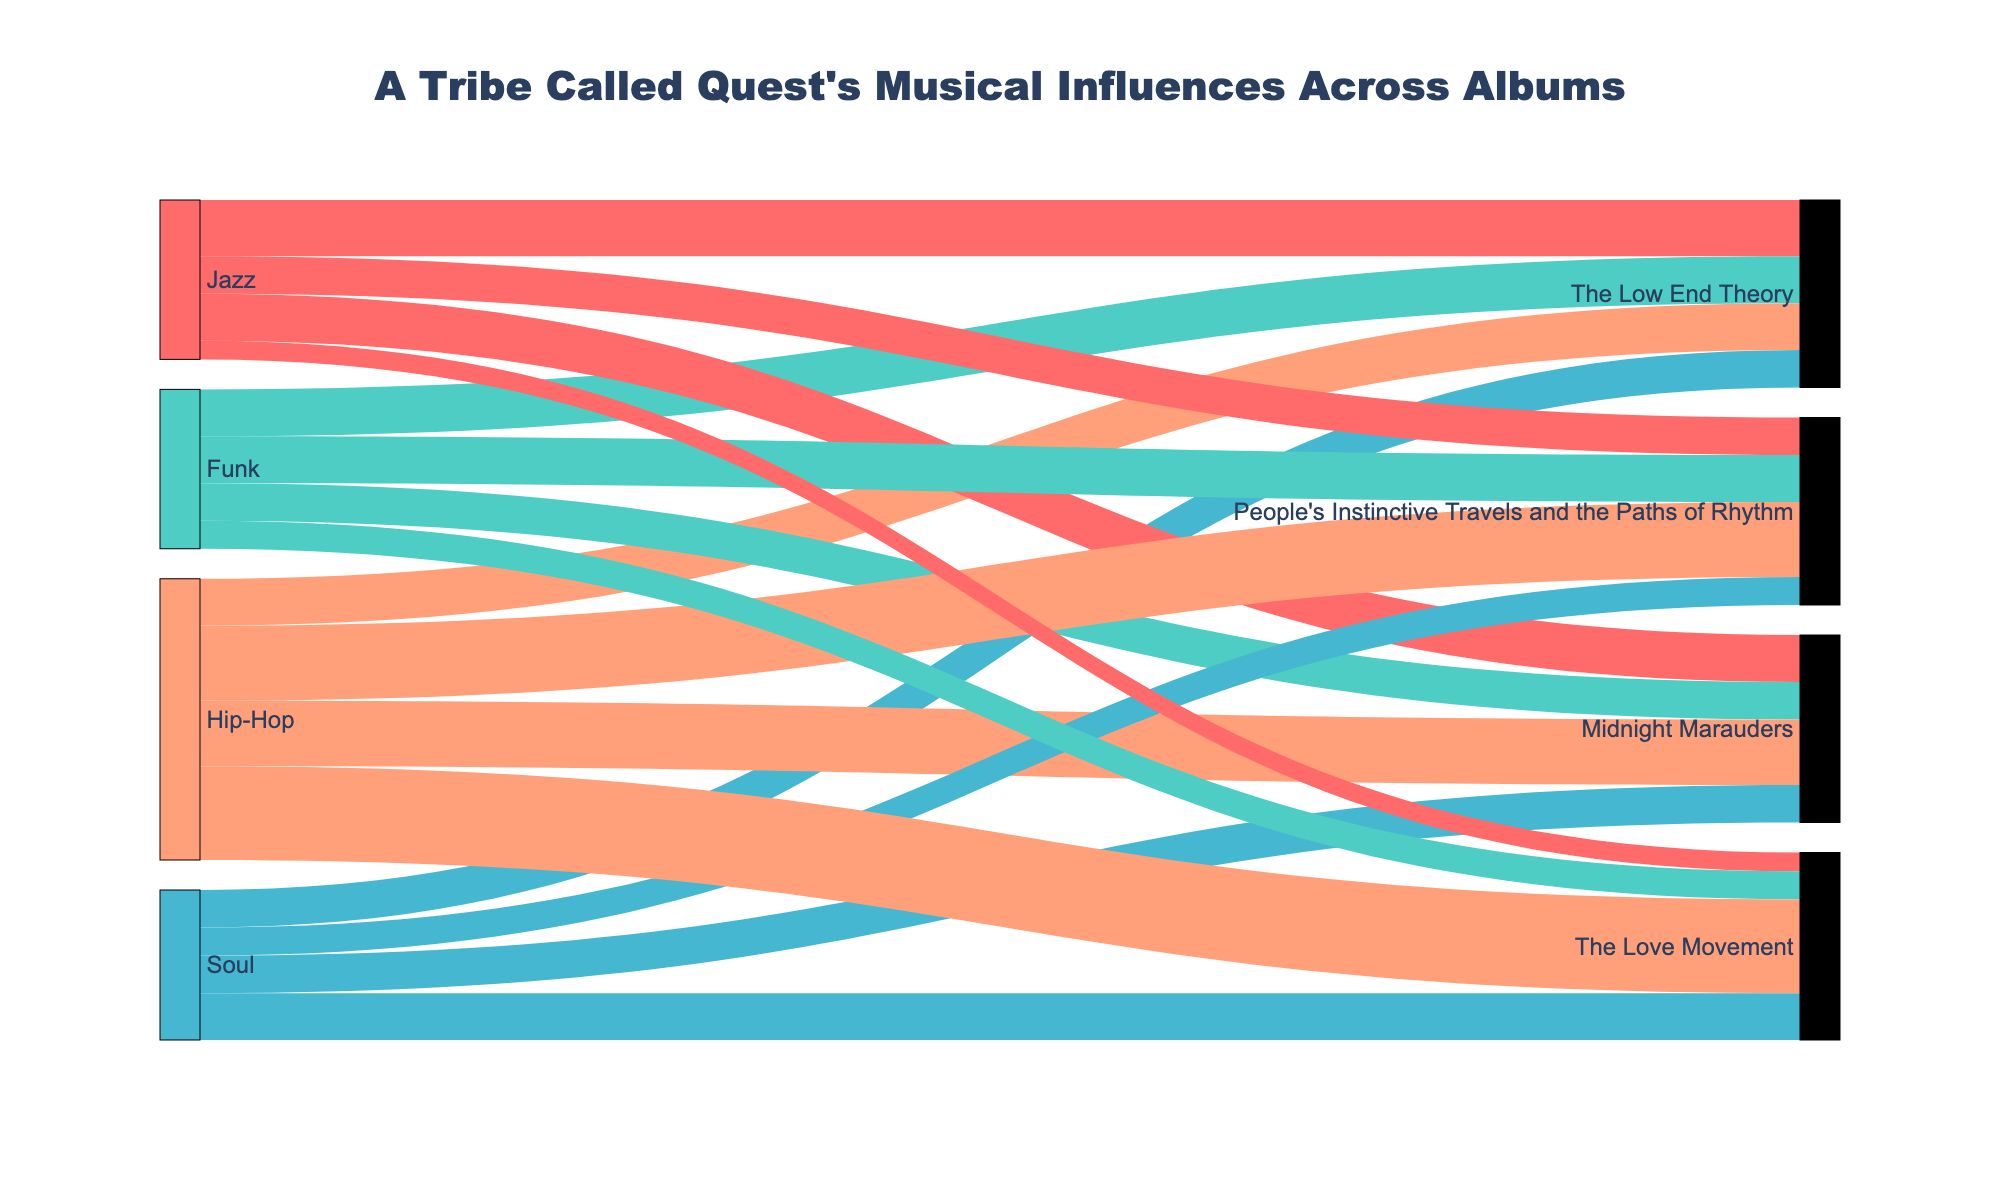What's the title of the figure? The title can be found at the top of the figure. It usually provides a summary of what the figure is about.
Answer: A Tribe Called Quest's Musical Influences Across Albums How many types of musical influences are shown? Identify the unique types of sources listed in the left part of the Sankey diagram.
Answer: Four (Jazz, Funk, Soul, Hip-Hop) How many albums are represented in the Sankey diagram? Look at the labels on the right side of the Sankey diagram, as these represent different albums.
Answer: Four (The Low End Theory, Midnight Marauders, People's Instinctive Travels and the Paths of Rhythm, The Love Movement) Which album has the highest influence from Hip-Hop? Compare the value of Hip-Hop influences for each album and find the highest number.
Answer: The Love Movement What's the combined influence of Funk on "Midnight Marauders" and "People's Instinctive Travels and the Paths of Rhythm"? Add the values of Funk influence on these two albums: 20 for Midnight Marauders and 25 for People's Instinctive Travels and the Paths of Rhythm.
Answer: 45 Which influence varies the least across the albums? Determine the range (difference between maximum and minimum values) of each influence across the albums. The smallest range indicates the least variation.
Answer: Soul What's the total Hip-Hop influence across all albums? Sum the values of Hip-Hop influences from all albums: 25 + 35 + 40 + 50.
Answer: 150 Which album has the lowest influence from Jazz? Compare the values of Jazz influences for each album and find the smallest number.
Answer: The Love Movement Rank the albums by the amount of Funk influence, highest to lowest. Order the albums based on the value of Funk influence from highest to lowest.
Answer: People's Instinctive Travels and the Paths of Rhythm, The Low End Theory, Midnight Marauders, The Love Movement How does the influence of Soul on "The Love Movement" compare to "The Low End Theory"? Compare the numbers directly. Soul influence on The Love Movement is 25, and on The Low End Theory is 20.
Answer: Higher 